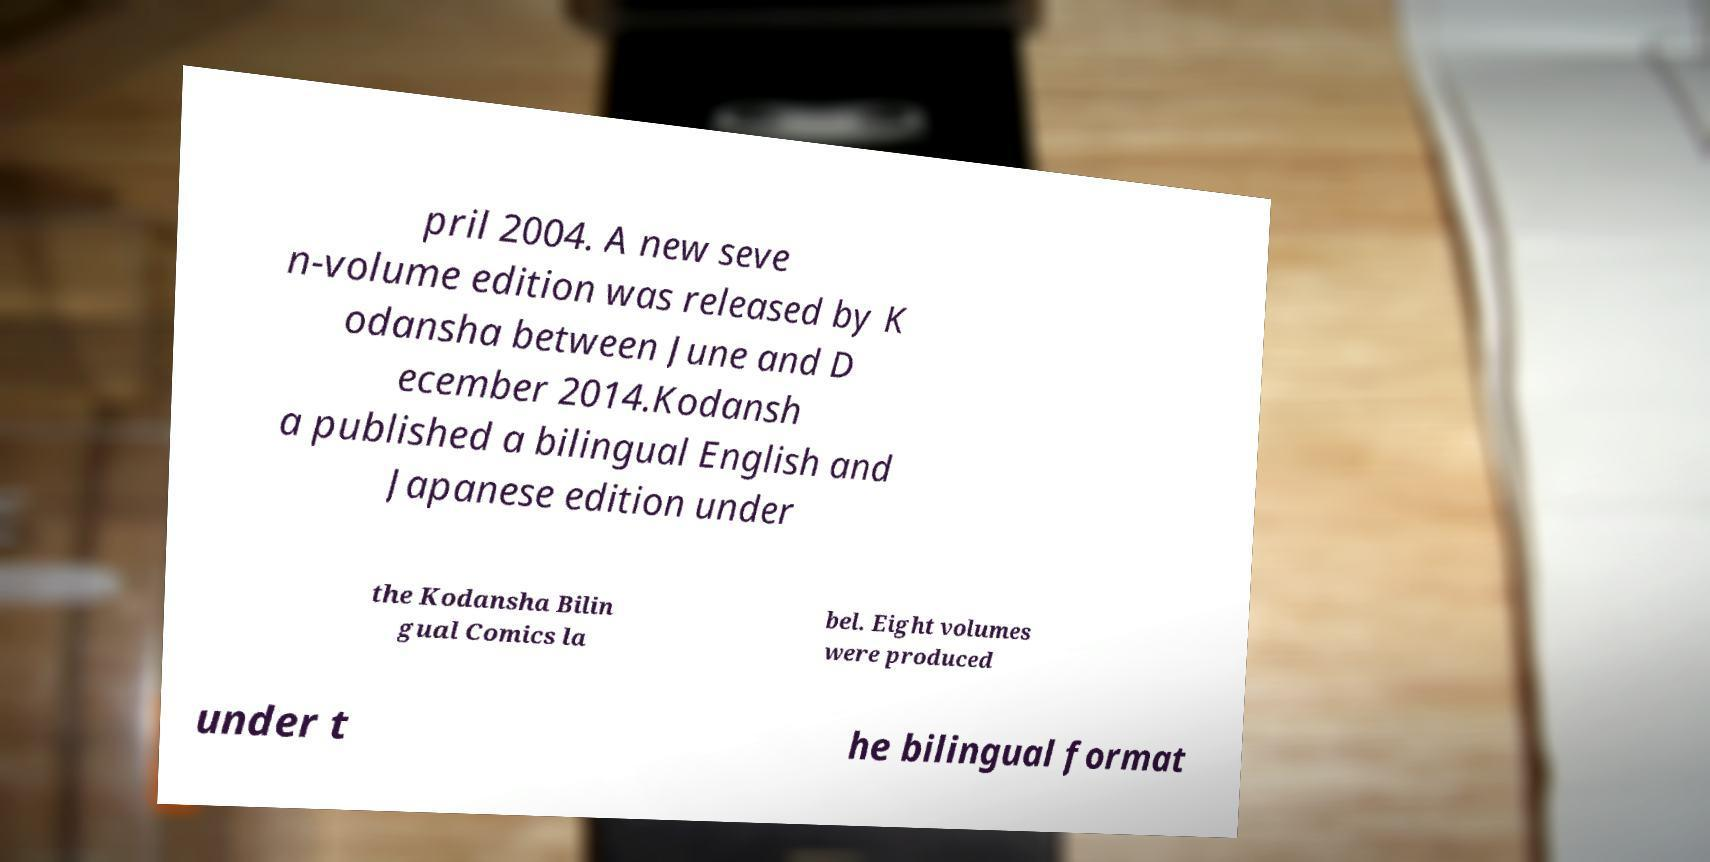I need the written content from this picture converted into text. Can you do that? pril 2004. A new seve n-volume edition was released by K odansha between June and D ecember 2014.Kodansh a published a bilingual English and Japanese edition under the Kodansha Bilin gual Comics la bel. Eight volumes were produced under t he bilingual format 